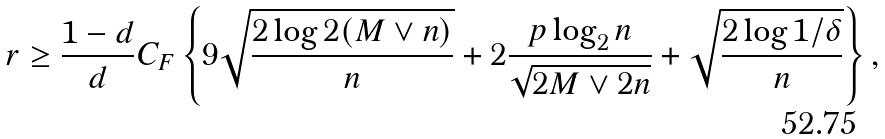<formula> <loc_0><loc_0><loc_500><loc_500>r \geq \frac { 1 - d } { d } C _ { F } \left \{ 9 \sqrt { \frac { 2 \log 2 ( M \vee n ) } { n } } + 2 \frac { p \log _ { 2 } n } { \sqrt { 2 M \vee 2 n } } + \sqrt { \frac { 2 \log 1 / \delta } { n } } \right \} ,</formula> 